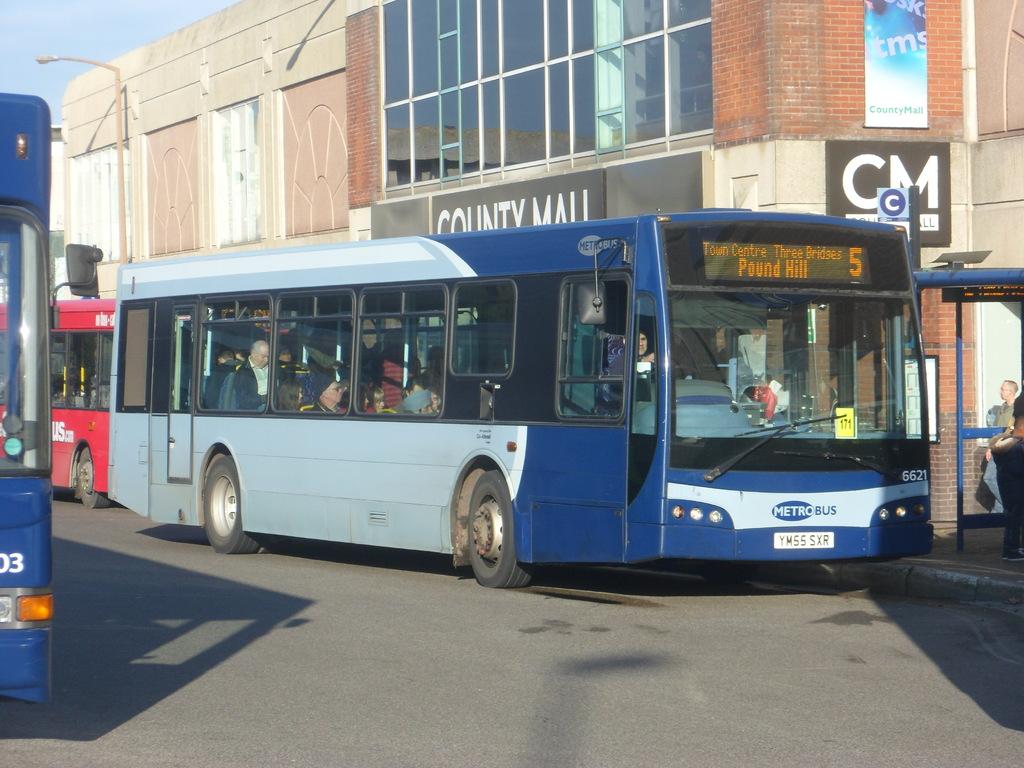What is the destination on the bus marquee?
Provide a short and direct response. Pound hill. 